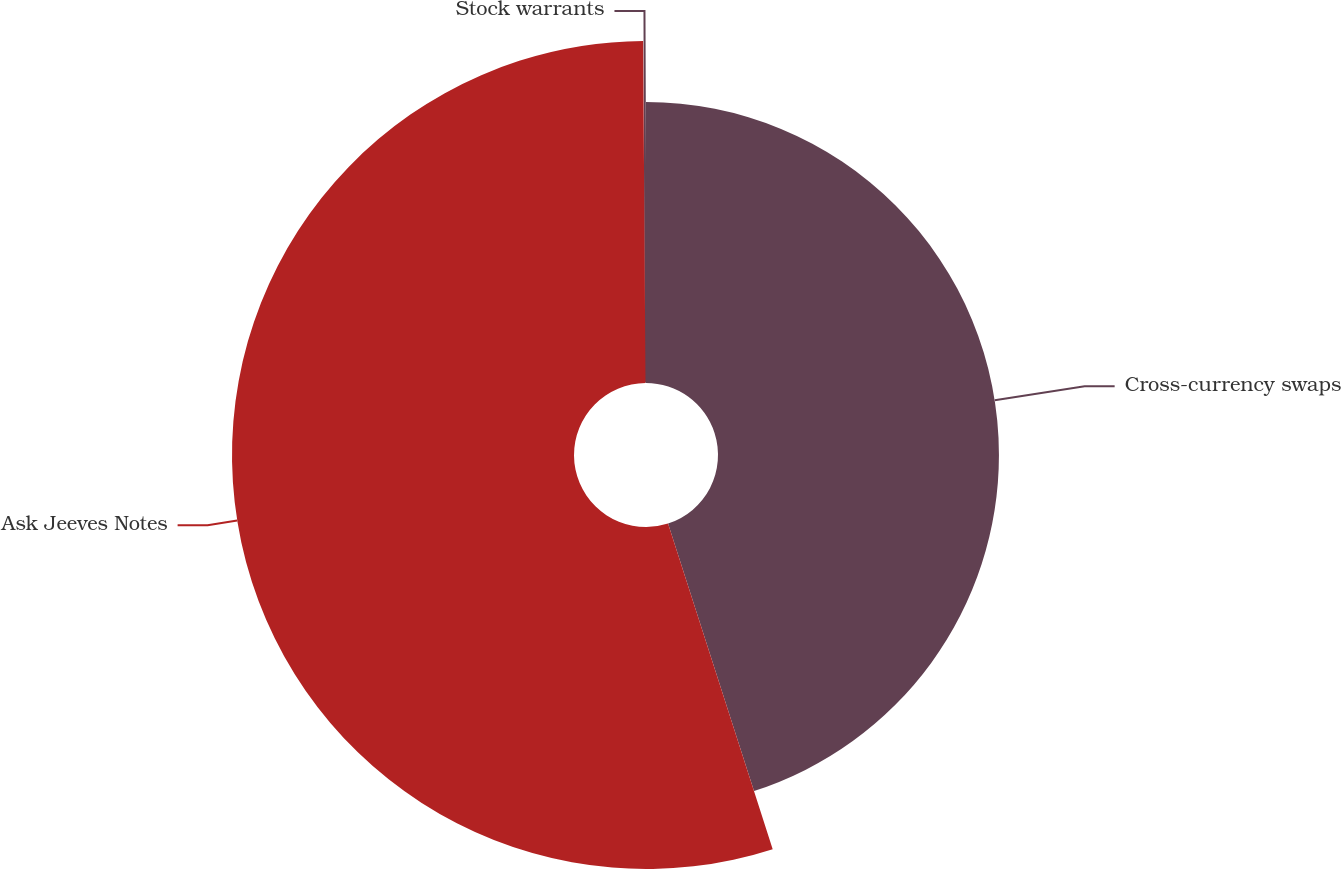Convert chart to OTSL. <chart><loc_0><loc_0><loc_500><loc_500><pie_chart><fcel>Cross-currency swaps<fcel>Ask Jeeves Notes<fcel>Stock warrants<nl><fcel>45.05%<fcel>54.84%<fcel>0.11%<nl></chart> 